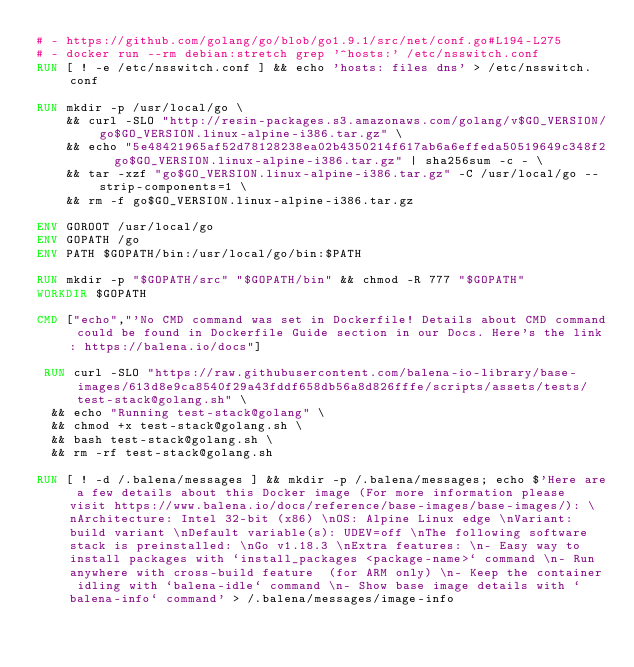Convert code to text. <code><loc_0><loc_0><loc_500><loc_500><_Dockerfile_># - https://github.com/golang/go/blob/go1.9.1/src/net/conf.go#L194-L275
# - docker run --rm debian:stretch grep '^hosts:' /etc/nsswitch.conf
RUN [ ! -e /etc/nsswitch.conf ] && echo 'hosts: files dns' > /etc/nsswitch.conf

RUN mkdir -p /usr/local/go \
	&& curl -SLO "http://resin-packages.s3.amazonaws.com/golang/v$GO_VERSION/go$GO_VERSION.linux-alpine-i386.tar.gz" \
	&& echo "5e48421965af52d78128238ea02b4350214f617ab6a6effeda50519649c348f2  go$GO_VERSION.linux-alpine-i386.tar.gz" | sha256sum -c - \
	&& tar -xzf "go$GO_VERSION.linux-alpine-i386.tar.gz" -C /usr/local/go --strip-components=1 \
	&& rm -f go$GO_VERSION.linux-alpine-i386.tar.gz

ENV GOROOT /usr/local/go
ENV GOPATH /go
ENV PATH $GOPATH/bin:/usr/local/go/bin:$PATH

RUN mkdir -p "$GOPATH/src" "$GOPATH/bin" && chmod -R 777 "$GOPATH"
WORKDIR $GOPATH

CMD ["echo","'No CMD command was set in Dockerfile! Details about CMD command could be found in Dockerfile Guide section in our Docs. Here's the link: https://balena.io/docs"]

 RUN curl -SLO "https://raw.githubusercontent.com/balena-io-library/base-images/613d8e9ca8540f29a43fddf658db56a8d826fffe/scripts/assets/tests/test-stack@golang.sh" \
  && echo "Running test-stack@golang" \
  && chmod +x test-stack@golang.sh \
  && bash test-stack@golang.sh \
  && rm -rf test-stack@golang.sh 

RUN [ ! -d /.balena/messages ] && mkdir -p /.balena/messages; echo $'Here are a few details about this Docker image (For more information please visit https://www.balena.io/docs/reference/base-images/base-images/): \nArchitecture: Intel 32-bit (x86) \nOS: Alpine Linux edge \nVariant: build variant \nDefault variable(s): UDEV=off \nThe following software stack is preinstalled: \nGo v1.18.3 \nExtra features: \n- Easy way to install packages with `install_packages <package-name>` command \n- Run anywhere with cross-build feature  (for ARM only) \n- Keep the container idling with `balena-idle` command \n- Show base image details with `balena-info` command' > /.balena/messages/image-info</code> 